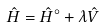<formula> <loc_0><loc_0><loc_500><loc_500>\hat { H } = \hat { H } ^ { \circ } + \lambda \hat { V }</formula> 